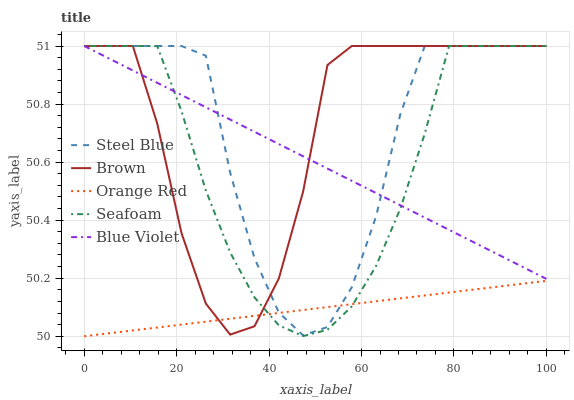Does Orange Red have the minimum area under the curve?
Answer yes or no. Yes. Does Brown have the maximum area under the curve?
Answer yes or no. Yes. Does Seafoam have the minimum area under the curve?
Answer yes or no. No. Does Seafoam have the maximum area under the curve?
Answer yes or no. No. Is Orange Red the smoothest?
Answer yes or no. Yes. Is Brown the roughest?
Answer yes or no. Yes. Is Seafoam the smoothest?
Answer yes or no. No. Is Seafoam the roughest?
Answer yes or no. No. Does Orange Red have the lowest value?
Answer yes or no. Yes. Does Seafoam have the lowest value?
Answer yes or no. No. Does Blue Violet have the highest value?
Answer yes or no. Yes. Does Orange Red have the highest value?
Answer yes or no. No. Is Orange Red less than Blue Violet?
Answer yes or no. Yes. Is Blue Violet greater than Orange Red?
Answer yes or no. Yes. Does Brown intersect Seafoam?
Answer yes or no. Yes. Is Brown less than Seafoam?
Answer yes or no. No. Is Brown greater than Seafoam?
Answer yes or no. No. Does Orange Red intersect Blue Violet?
Answer yes or no. No. 